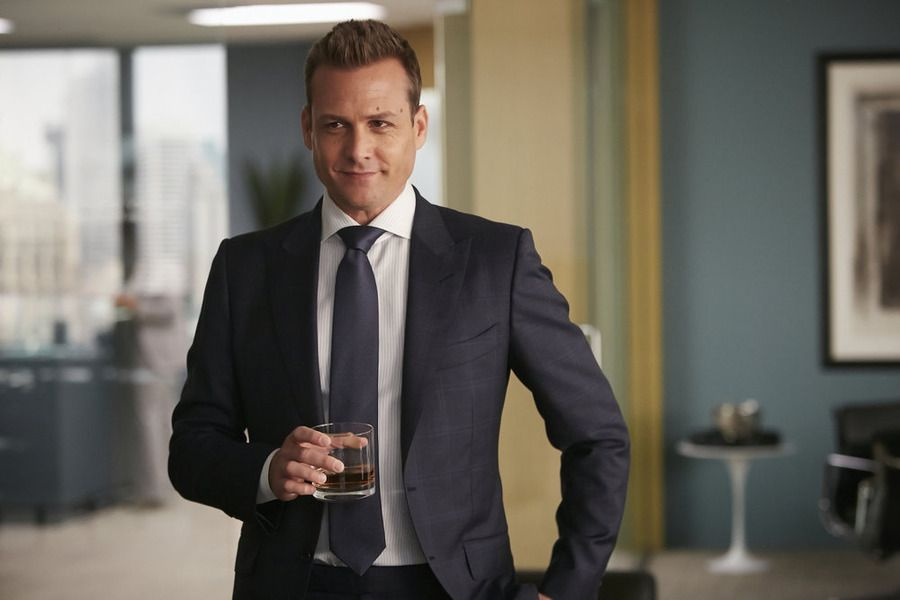Imagine a dramatic event occurring in this office. What could it be? Picture this: As the man approaches his window to observe the bustling city below, the tranquil setting is abruptly interrupted by the arrival of a distressed colleague. The colleague rushes in, a stack of documents in hand, frantically exclaiming that a critical deal is on the brink of collapse. The character's calm demeanor shifts to a focused state, as he quickly assesses the situation and begins strategizing a solution. The atmosphere in the office transforms from serene to tense, highlighting the high-stakes environment in which such power players operate. 